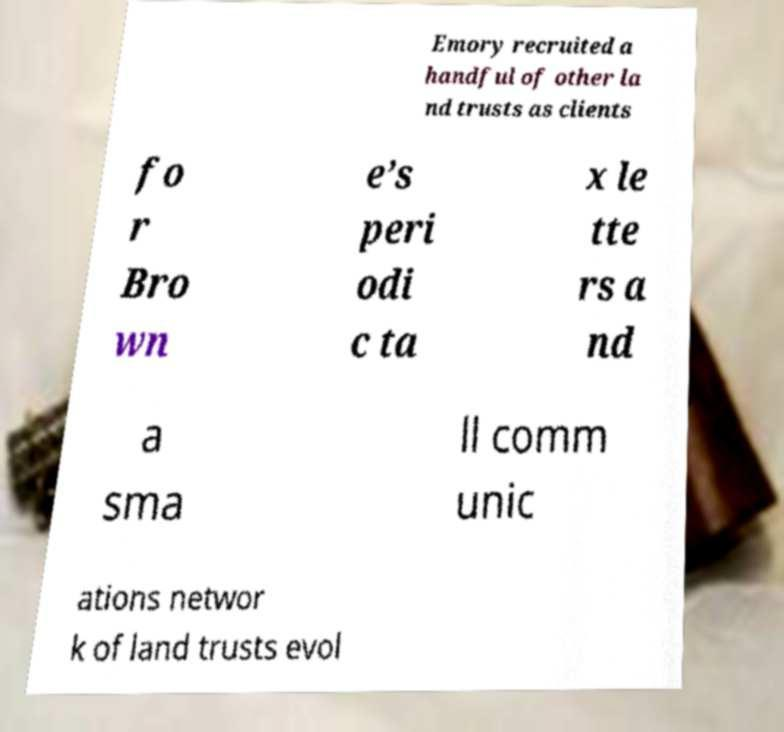Please identify and transcribe the text found in this image. Emory recruited a handful of other la nd trusts as clients fo r Bro wn e’s peri odi c ta x le tte rs a nd a sma ll comm unic ations networ k of land trusts evol 